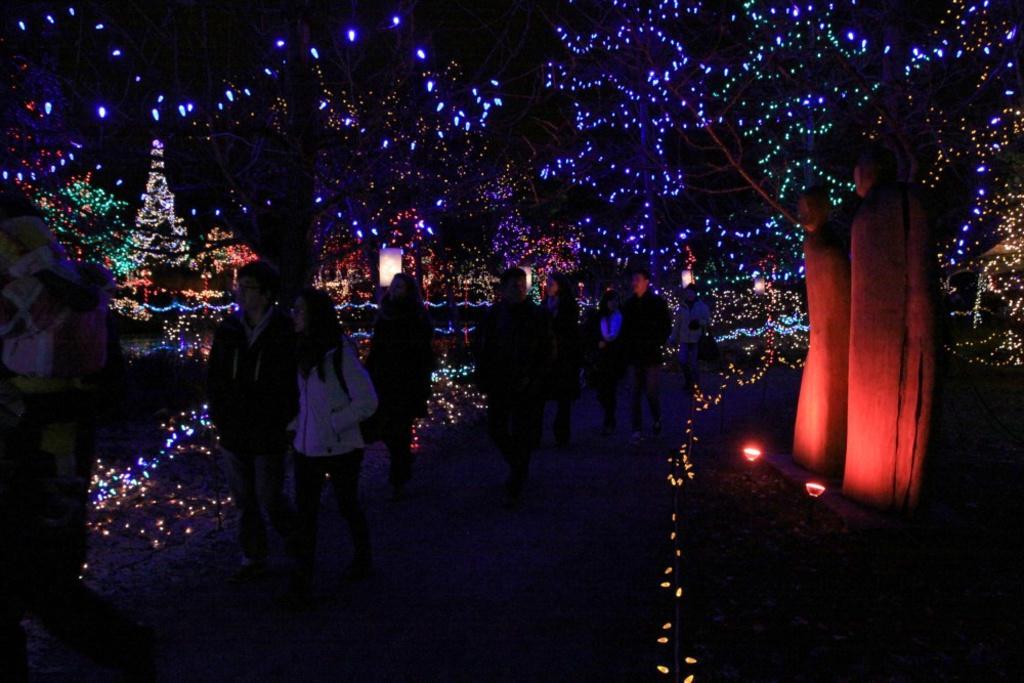Describe this image in one or two sentences. In this image we can see decoration with Christmas lights. In the middle of the image people are walking path way. Right side of the image tree bark is there. 